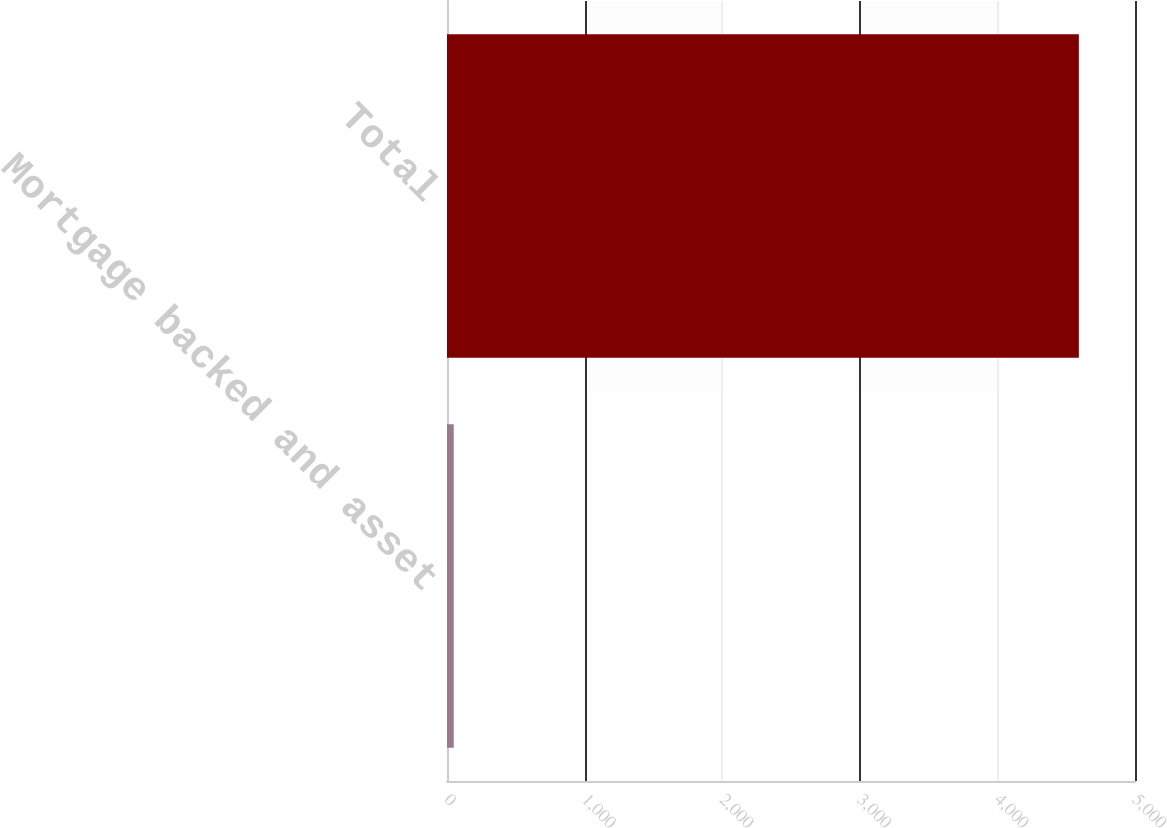Convert chart to OTSL. <chart><loc_0><loc_0><loc_500><loc_500><bar_chart><fcel>Mortgage backed and asset<fcel>Total<nl><fcel>49<fcel>4592<nl></chart> 